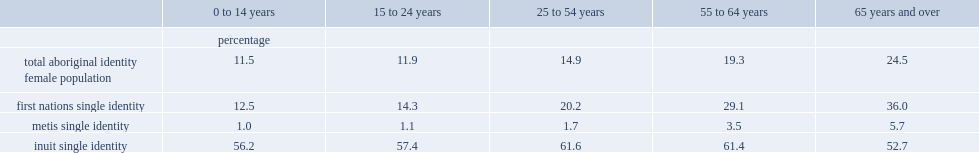What was the percent of aboriginal girls under the age of 15 reported an aboriginal mother tongue? 11.5. What was the percent of aboriginal girls aged 25 to 54 years reported an aboriginal mother tongue? 14.9. What was the percent of aboriginal women aged 65 and over reported an aboriginal mother tongue? 24.5. What was the percent of first nations females under the age of 15 reporting an aboriginal mother tongue? 12.5. What was the percent of first nations females aged 65 and over reporting an aboriginal mother tongue? 36.0. Among metis women aged 65 and over, how many percentages reported an aboriginal mother tongue? 5.7. What was the proportions for metis girls aged 25 to 54 years? 1.7. What was the proportions for metis girls aged 14 and under? 1.0. The pattern of reporting an aboriginal mother tongue is slightly different among inuit women and girls, what was the proportion for those aged 25 to 54 years? 61.6. What was the proportion reporting an aboriginal mother tongue for inuit women under the age of 15? 56.2. What was the proportion reporting an aboriginal mother tongue for inuit women aged 65 and over? 52.7. 